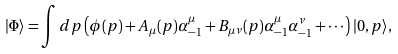<formula> <loc_0><loc_0><loc_500><loc_500>| \Phi \rangle = \int d p \left ( \phi ( p ) + A _ { \mu } ( p ) \alpha _ { - 1 } ^ { \mu } + B _ { \mu \nu } ( p ) \alpha _ { - 1 } ^ { \mu } \alpha _ { - 1 } ^ { \nu } + \cdots \right ) | 0 , p \rangle ,</formula> 